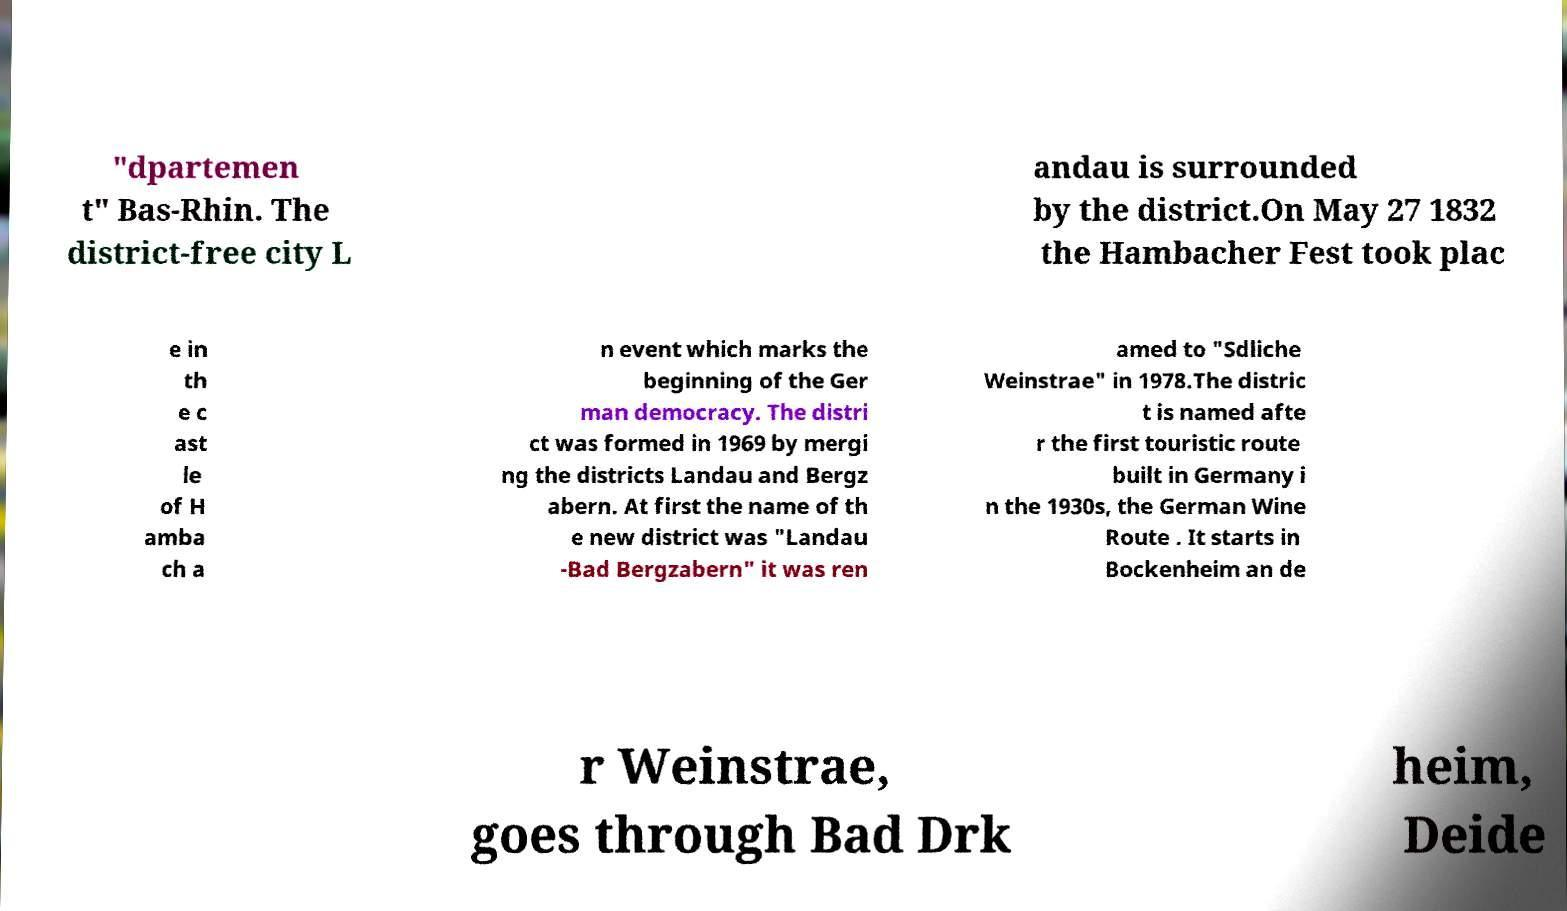Please read and relay the text visible in this image. What does it say? "dpartemen t" Bas-Rhin. The district-free city L andau is surrounded by the district.On May 27 1832 the Hambacher Fest took plac e in th e c ast le of H amba ch a n event which marks the beginning of the Ger man democracy. The distri ct was formed in 1969 by mergi ng the districts Landau and Bergz abern. At first the name of th e new district was "Landau -Bad Bergzabern" it was ren amed to "Sdliche Weinstrae" in 1978.The distric t is named afte r the first touristic route built in Germany i n the 1930s, the German Wine Route . It starts in Bockenheim an de r Weinstrae, goes through Bad Drk heim, Deide 